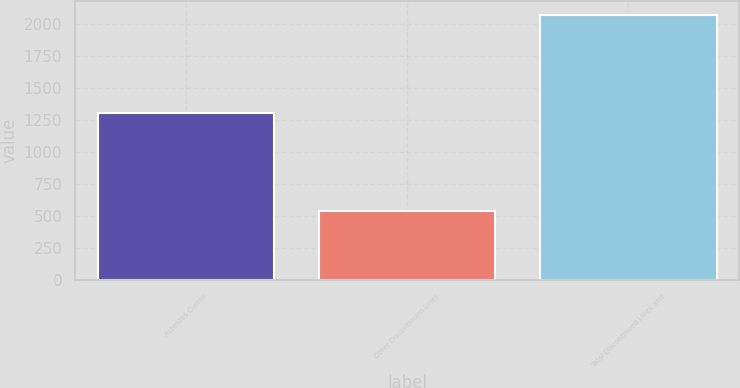<chart> <loc_0><loc_0><loc_500><loc_500><bar_chart><fcel>Asbestos Claims<fcel>Other Discontinued Lines<fcel>Total Discontinued Lines and<nl><fcel>1302<fcel>541<fcel>2075<nl></chart> 